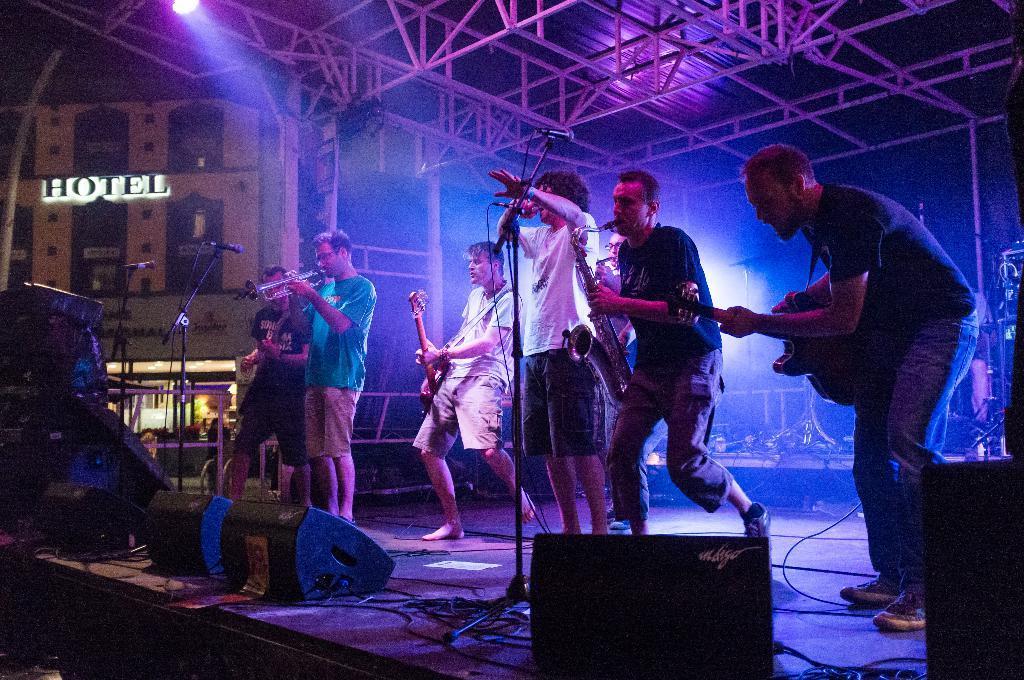Describe this image in one or two sentences. In this image I can see a group of people are playing musical instruments on the stage in front of a microphone 